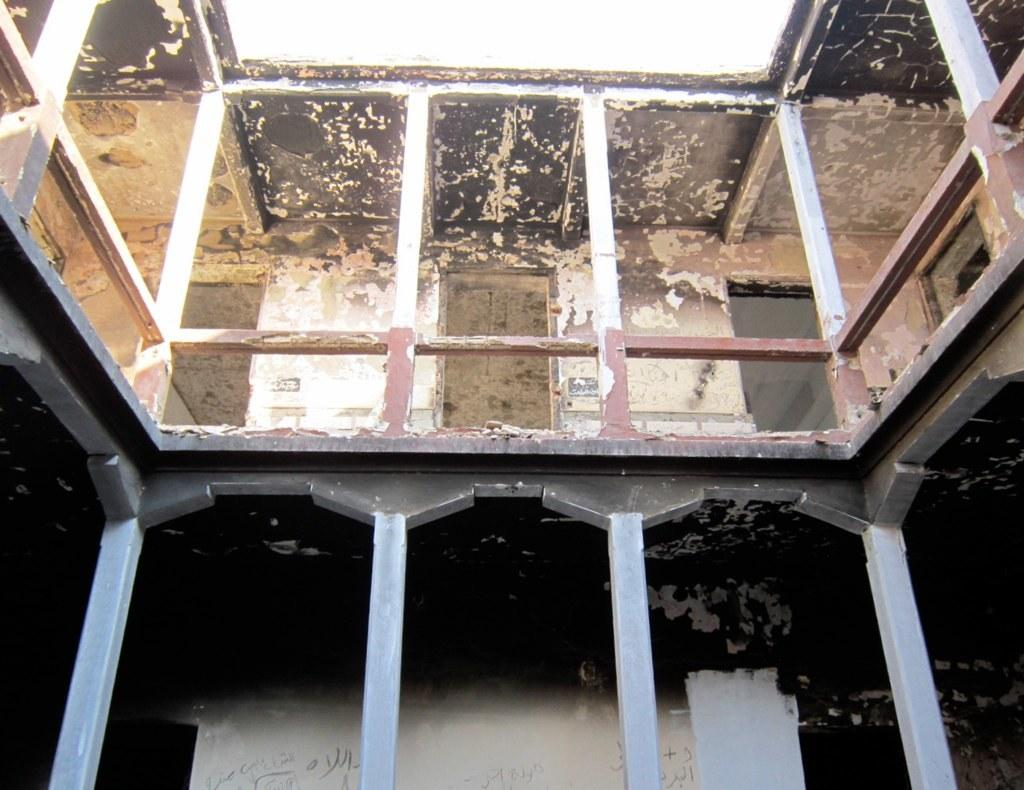What type of structure is visible in the image? There is a building in the image. What architectural features can be seen on the building? The building has pillars, railings, walls, and a ceiling. How many monkeys are sitting on the roof of the building in the image? There are no monkeys present in the image, so it is not possible to determine the number of monkeys on the roof. 